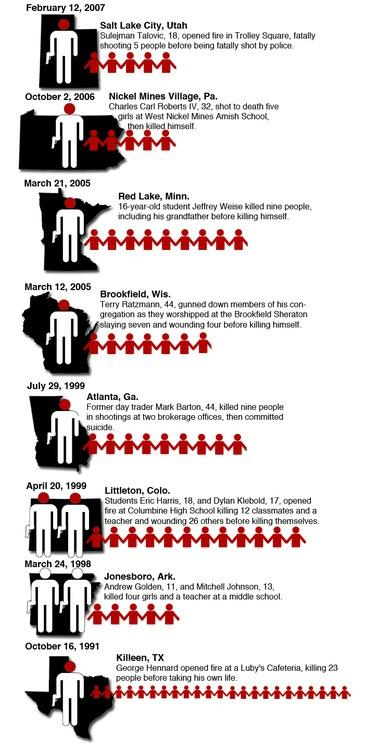Mention a couple of crucial points in this snapshot. In 2005, there were 2 shooting incidents reported. Littleton, Colorado reported the number of causalities to be 12. In 1991, there were the highest number of causalities due to shooting incidents. The shooting incident at Colorado occurred at Columbine High school. The shooter in Atlanta was 44 years old. 